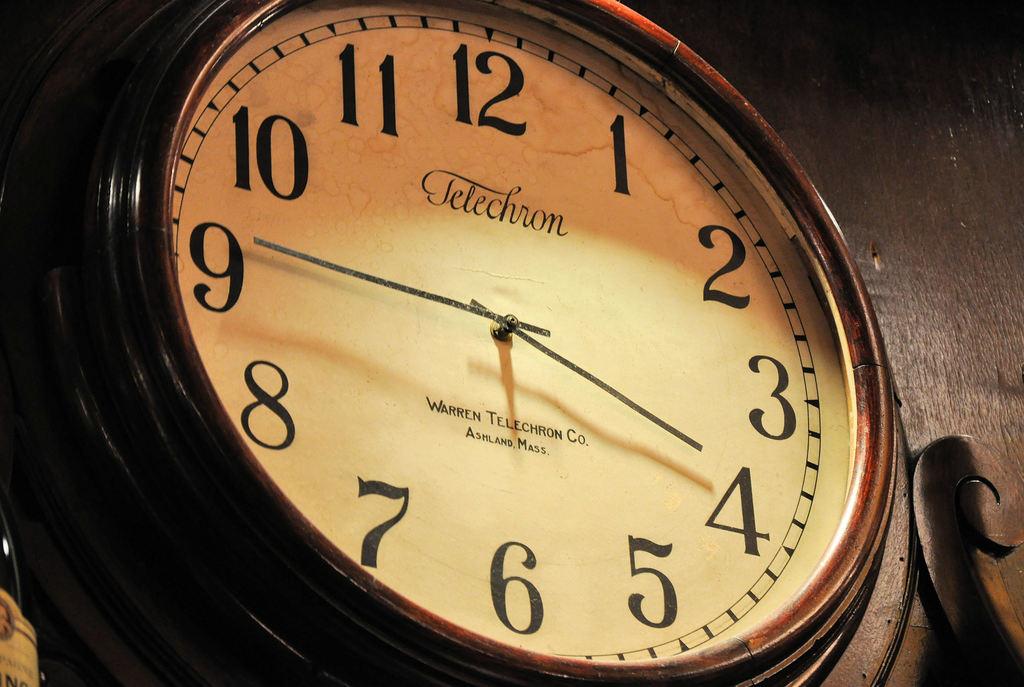What time is it?
Offer a terse response. 3:45. 